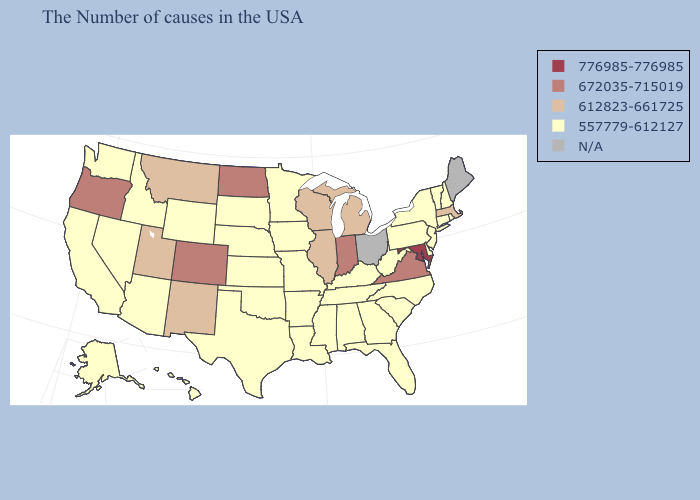Does Washington have the lowest value in the USA?
Write a very short answer. Yes. Name the states that have a value in the range 612823-661725?
Quick response, please. Massachusetts, Michigan, Wisconsin, Illinois, New Mexico, Utah, Montana. Does Maryland have the highest value in the USA?
Give a very brief answer. Yes. What is the value of New Hampshire?
Concise answer only. 557779-612127. Does Massachusetts have the lowest value in the USA?
Give a very brief answer. No. Which states hav the highest value in the MidWest?
Concise answer only. Indiana, North Dakota. What is the value of Nevada?
Give a very brief answer. 557779-612127. Among the states that border Kentucky , does Illinois have the lowest value?
Keep it brief. No. What is the value of Oregon?
Short answer required. 672035-715019. What is the value of Indiana?
Quick response, please. 672035-715019. What is the highest value in states that border Maryland?
Short answer required. 672035-715019. Which states have the lowest value in the USA?
Short answer required. Rhode Island, New Hampshire, Vermont, Connecticut, New York, New Jersey, Delaware, Pennsylvania, North Carolina, South Carolina, West Virginia, Florida, Georgia, Kentucky, Alabama, Tennessee, Mississippi, Louisiana, Missouri, Arkansas, Minnesota, Iowa, Kansas, Nebraska, Oklahoma, Texas, South Dakota, Wyoming, Arizona, Idaho, Nevada, California, Washington, Alaska, Hawaii. Among the states that border New Jersey , which have the lowest value?
Quick response, please. New York, Delaware, Pennsylvania. 